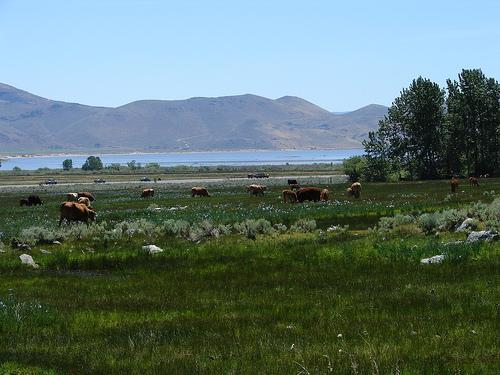Briefly describe the weather conditions shown in the image. The image displays clear blue skies, suggesting a sunny day with good weather. What different types of animals are depicted in the image? There are cows in various groups, some grazing alone and others in groups. What color and type of vehicle is driving on the road? There is a blue car driving on the highway. Mention the different types of vegetation present in the image. The image features evergreen trees, wildflowers, tall grass, scrub bushes, and scraggly flowers. Identify the type of field in the image and what can be found in it. The image shows a pasture with cows grazing, wildflowers, green grass, white rocks, and scrub bushes. What objects can be seen next to the field? We can see pine trees growing next to the field, a group of green trees, and a highway with cars driving on it. Give a brief description of the landscape in the image. The landscape includes a pasture with grazing cows, a lake, distant mountains, and a highway with cars driving on it. Provide an estimation for the number of cows present in the picture. There is a group of six cows, a cow grazing alone, and grazing cattle, totaling approximately eight cows. What type of water body can be seen in the image? A clear blue lake or river is visible in the image. Point out the items that are either blue or white in the image. The items that are blue or white in the image are the blue car on the road, white rock in the field, blue lake or river, white flowers in the pasture, and clear blue sky. 